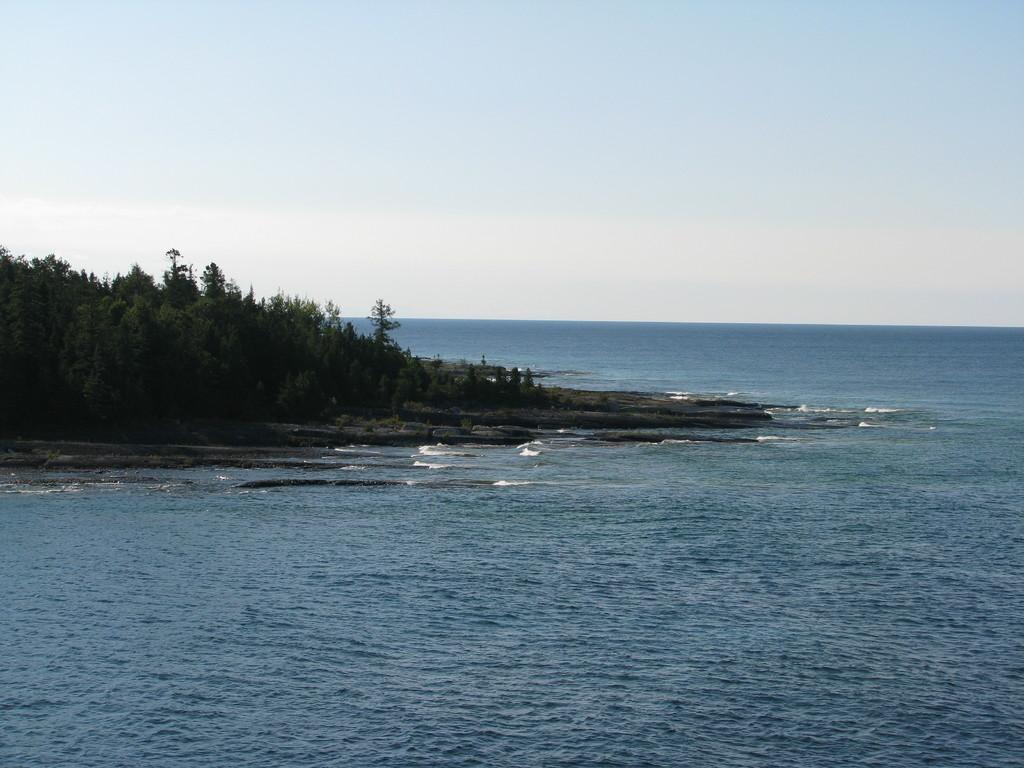Describe this image in one or two sentences. In this image we can see group of trees ,water and in the background,we can see the sky. 